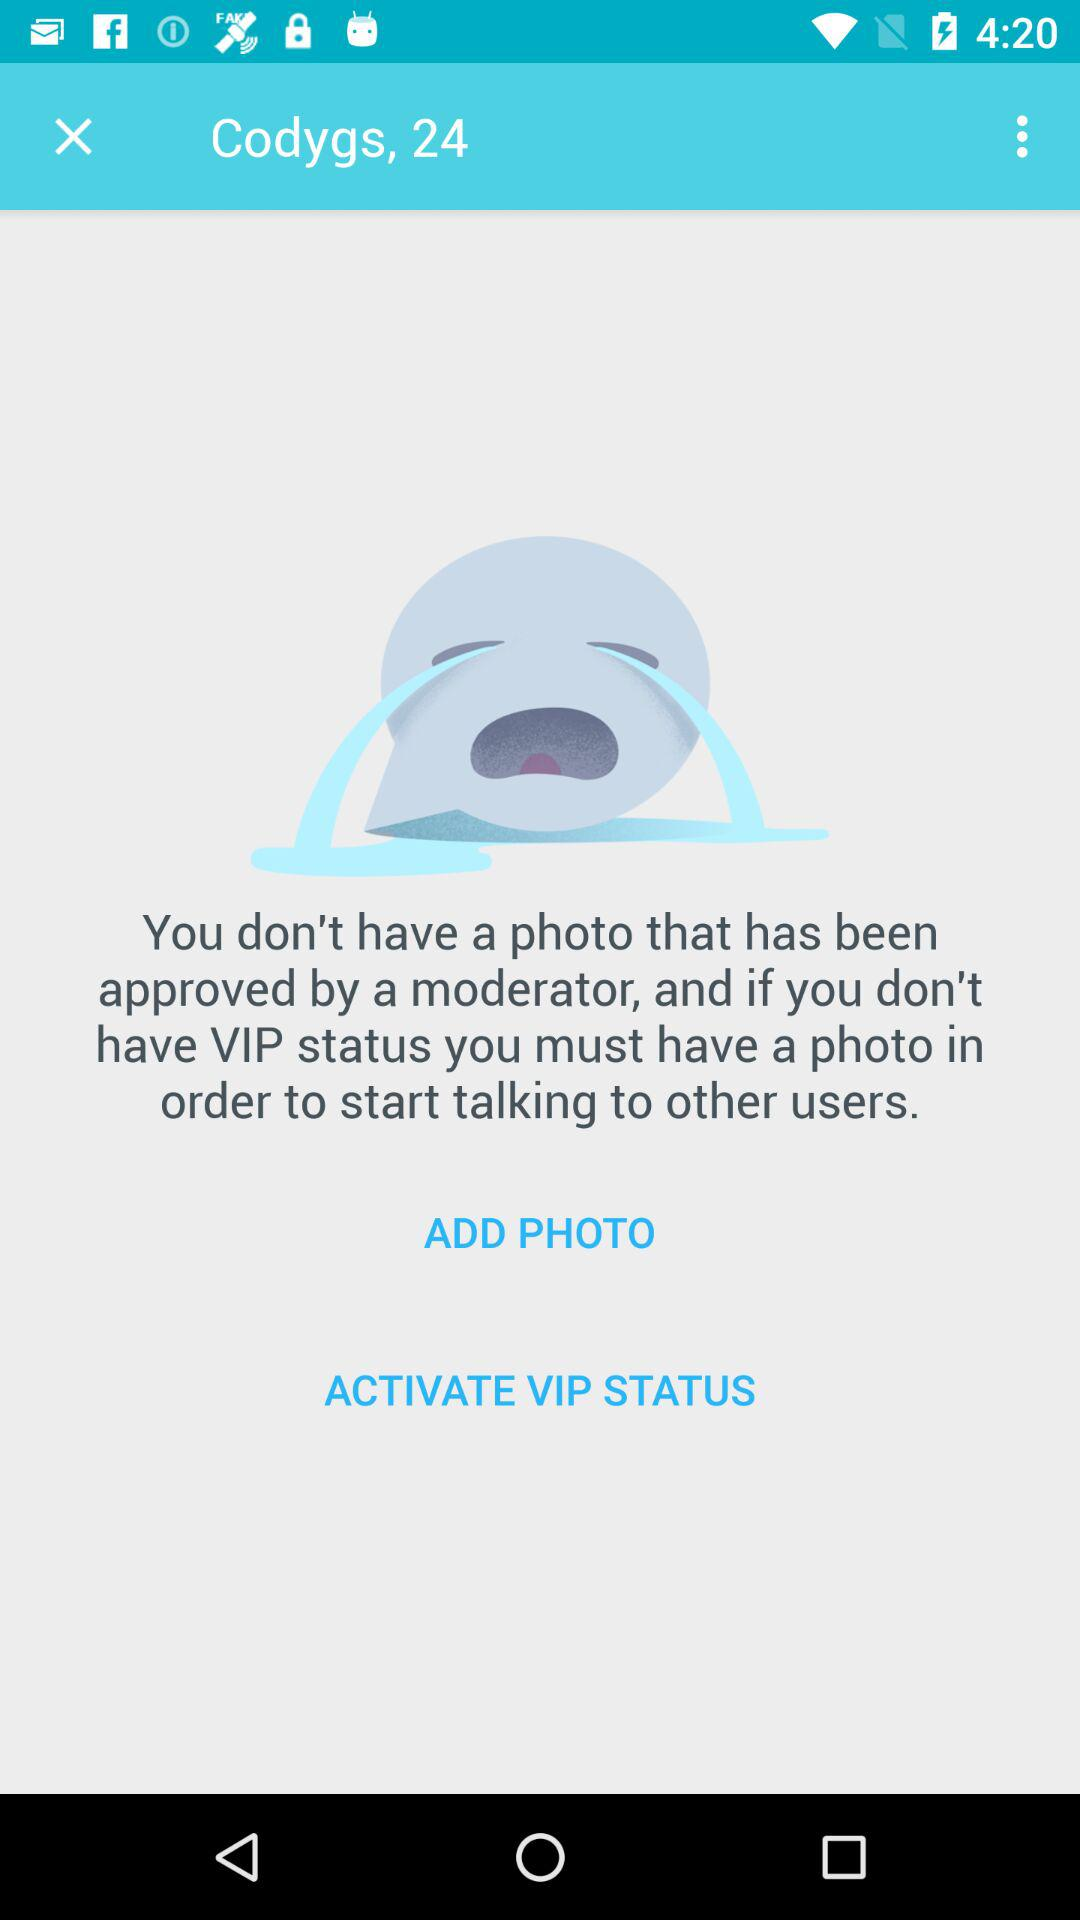What is the username? The username is Codygs. 